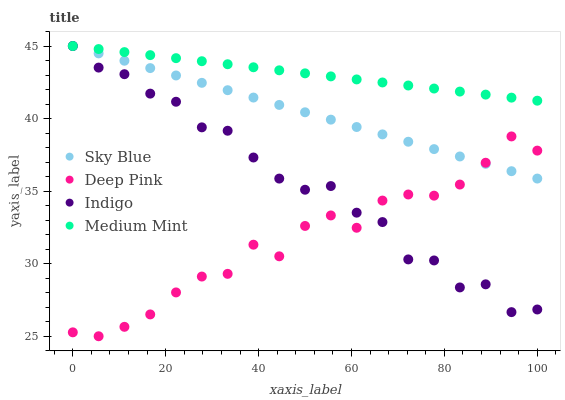Does Deep Pink have the minimum area under the curve?
Answer yes or no. Yes. Does Medium Mint have the maximum area under the curve?
Answer yes or no. Yes. Does Sky Blue have the minimum area under the curve?
Answer yes or no. No. Does Sky Blue have the maximum area under the curve?
Answer yes or no. No. Is Sky Blue the smoothest?
Answer yes or no. Yes. Is Indigo the roughest?
Answer yes or no. Yes. Is Deep Pink the smoothest?
Answer yes or no. No. Is Deep Pink the roughest?
Answer yes or no. No. Does Deep Pink have the lowest value?
Answer yes or no. Yes. Does Sky Blue have the lowest value?
Answer yes or no. No. Does Indigo have the highest value?
Answer yes or no. Yes. Does Deep Pink have the highest value?
Answer yes or no. No. Is Deep Pink less than Medium Mint?
Answer yes or no. Yes. Is Medium Mint greater than Deep Pink?
Answer yes or no. Yes. Does Sky Blue intersect Medium Mint?
Answer yes or no. Yes. Is Sky Blue less than Medium Mint?
Answer yes or no. No. Is Sky Blue greater than Medium Mint?
Answer yes or no. No. Does Deep Pink intersect Medium Mint?
Answer yes or no. No. 